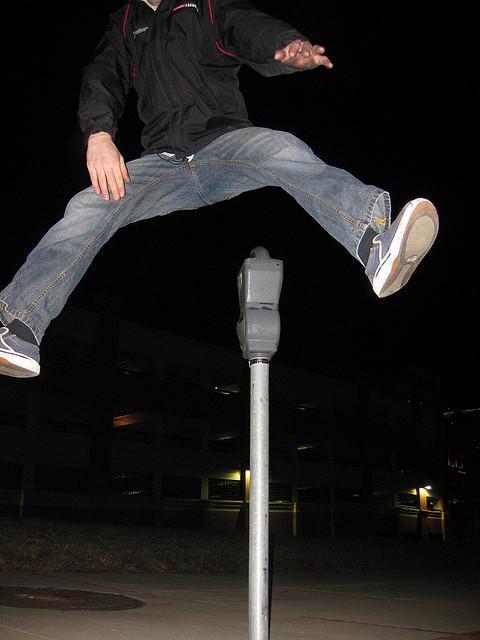How many pieces of chocolate cake are on the white plate?
Give a very brief answer. 0. 